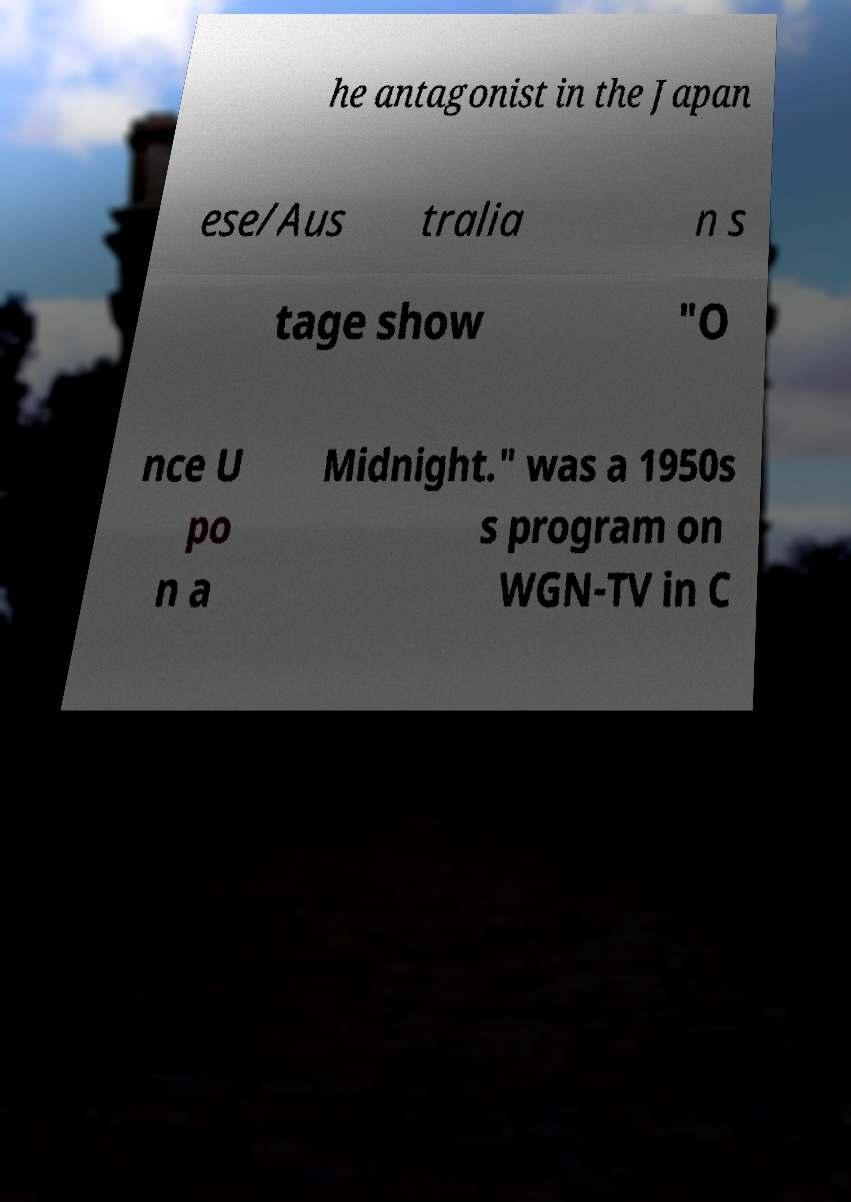What messages or text are displayed in this image? I need them in a readable, typed format. he antagonist in the Japan ese/Aus tralia n s tage show "O nce U po n a Midnight." was a 1950s s program on WGN-TV in C 